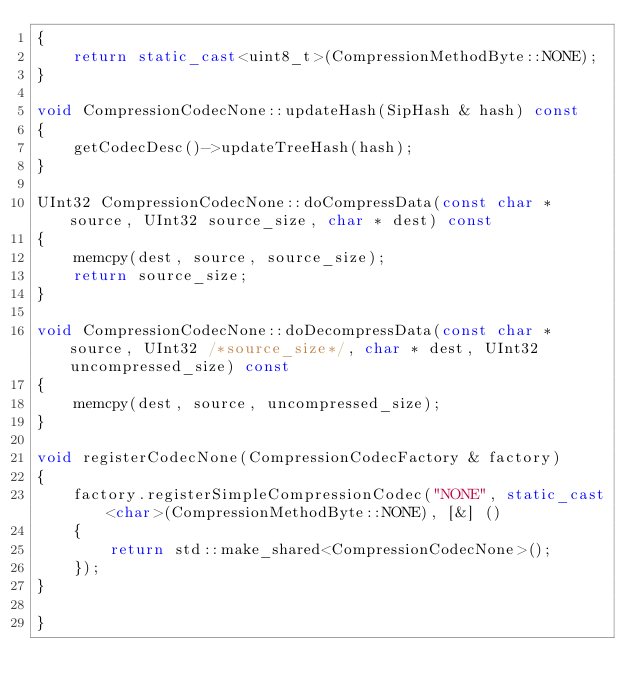Convert code to text. <code><loc_0><loc_0><loc_500><loc_500><_C++_>{
    return static_cast<uint8_t>(CompressionMethodByte::NONE);
}

void CompressionCodecNone::updateHash(SipHash & hash) const
{
    getCodecDesc()->updateTreeHash(hash);
}

UInt32 CompressionCodecNone::doCompressData(const char * source, UInt32 source_size, char * dest) const
{
    memcpy(dest, source, source_size);
    return source_size;
}

void CompressionCodecNone::doDecompressData(const char * source, UInt32 /*source_size*/, char * dest, UInt32 uncompressed_size) const
{
    memcpy(dest, source, uncompressed_size);
}

void registerCodecNone(CompressionCodecFactory & factory)
{
    factory.registerSimpleCompressionCodec("NONE", static_cast<char>(CompressionMethodByte::NONE), [&] ()
    {
        return std::make_shared<CompressionCodecNone>();
    });
}

}
</code> 